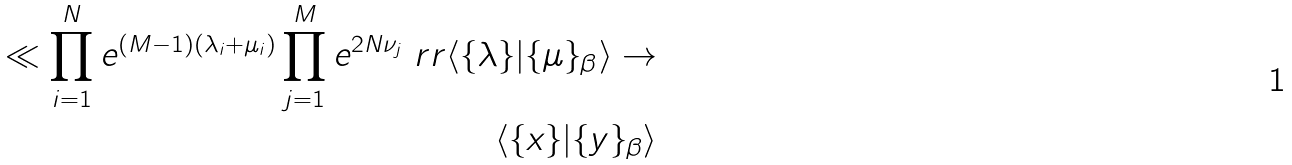<formula> <loc_0><loc_0><loc_500><loc_500>\ll \prod _ { i = 1 } ^ { N } e ^ { ( M - 1 ) ( \lambda _ { i } + \mu _ { i } ) } \prod _ { j = 1 } ^ { M } e ^ { 2 N \nu _ { j } } \ r r \langle \{ \lambda \} | \{ \mu \} _ { \beta } \rangle \rightarrow \\ \langle \{ x \} | \{ y \} _ { \beta } \rangle</formula> 